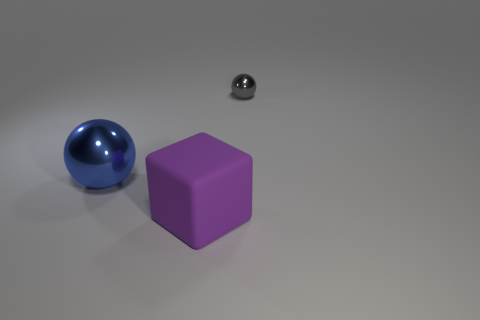There is another object that is the same shape as the small metallic object; what material is it?
Your answer should be very brief. Metal. Are there more things left of the tiny shiny sphere than blue balls behind the large purple block?
Offer a terse response. Yes. The small thing that is the same material as the big blue thing is what shape?
Ensure brevity in your answer.  Sphere. Is the number of shiny things that are behind the matte object greater than the number of rubber things?
Keep it short and to the point. Yes. What number of metallic balls have the same color as the small shiny thing?
Provide a short and direct response. 0. How many other objects are the same color as the large metal sphere?
Offer a terse response. 0. Are there more large brown balls than tiny things?
Give a very brief answer. No. What material is the big blue thing?
Provide a short and direct response. Metal. There is a purple cube that is in front of the gray metal sphere; is its size the same as the blue thing?
Provide a succinct answer. Yes. There is a metal object behind the big blue metal sphere; what size is it?
Give a very brief answer. Small. 